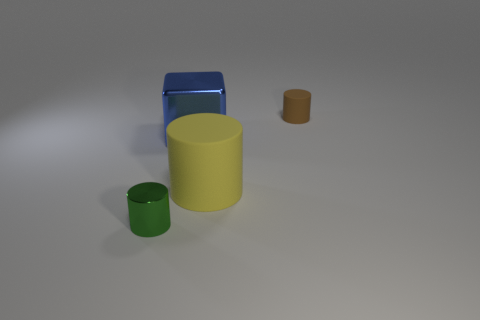How many spheres are either green objects or large metallic objects?
Give a very brief answer. 0. There is a small cylinder that is right of the large metal block; what material is it?
Offer a terse response. Rubber. Are there fewer brown cylinders than tiny brown balls?
Offer a very short reply. No. There is a object that is both on the left side of the yellow rubber cylinder and on the right side of the green cylinder; how big is it?
Ensure brevity in your answer.  Large. What is the size of the rubber thing in front of the tiny cylinder that is behind the large matte cylinder in front of the small brown cylinder?
Your response must be concise. Large. There is a tiny object to the right of the large shiny block; is it the same color as the metallic block?
Keep it short and to the point. No. How many things are large objects or red matte blocks?
Give a very brief answer. 2. The rubber thing behind the blue metallic thing is what color?
Make the answer very short. Brown. Are there fewer tiny green shiny cylinders right of the big matte cylinder than green cubes?
Make the answer very short. No. Is there any other thing that has the same size as the blue cube?
Ensure brevity in your answer.  Yes. 